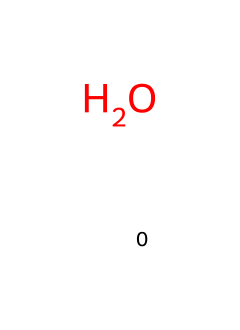What is the chemical formula of this molecule? The chemical formula represents the number and type of atoms in the molecule. This molecule consists solely of one oxygen atom, which indicates the formula is simply O.
Answer: O How many atoms are in this molecule? The molecule contains one oxygen atom. Counting the number of atoms gives us a total of one.
Answer: 1 What type of molecule is represented here? The structure of this molecule includes only one type of atom (oxygen) and suggests it is a simple molecular species, specifically classified as a diatomic molecule or more simply as elemental oxygen.
Answer: elemental oxygen What is the state of this substance at room temperature? Elemental oxygen typically exists as a gas at room temperature (about 20 degrees Celsius). Given its elemental nature and standard conditions, we conclude that it is gaseous.
Answer: gas How many bonds does this molecule typically form in its most stable state? In its diatomic molecular form (O2), oxygen typically forms a double bond between two oxygen atoms. In this case of single oxygen appearing alone, the question pertains to individual atoms rather than bonding with others. Thus, in this representation, no bonds form since it's a single atom.
Answer: 0 What is the significance of isotopes in water molecules? Isotopes refer to variants of an element that have the same number of protons but differ in neutrons. In terms of water, isotopes of hydrogen (like deuterium) and oxygen can create different compositions of water molecules, affecting properties like evaporation and precipitation patterns in regional studies.
Answer: isotopes affect properties Which stable isotopes are commonly found in water? The most prevalent isotopes of hydrogen found in water are protium (1H) and deuterium (2H), while for oxygen, the stable isotopes are primarily oxygen-16 (16O) and oxygen-18 (18O). This distinction informs various studies related to hydrology and climate.
Answer: 1H, 2H, 16O, 18O 